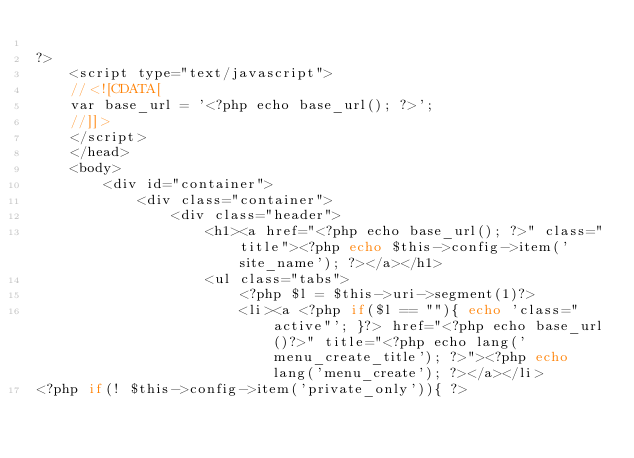Convert code to text. <code><loc_0><loc_0><loc_500><loc_500><_PHP_>
?>
	<script type="text/javascript">
	//<![CDATA[
	var base_url = '<?php echo base_url(); ?>';
	//]]>
	</script>
	</head>
	<body>
		<div id="container">
			<div class="container">			
				<div class="header">
					<h1><a href="<?php echo base_url(); ?>" class="title"><?php echo $this->config->item('site_name'); ?></a></h1>
					<ul class="tabs">
						<?php $l = $this->uri->segment(1)?>
						<li><a <?php if($l == ""){ echo 'class="active"'; }?> href="<?php echo base_url()?>" title="<?php echo lang('menu_create_title'); ?>"><?php echo lang('menu_create'); ?></a></li>
<?php if(! $this->config->item('private_only')){ ?></code> 